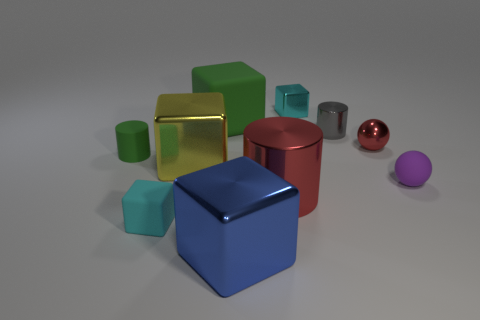How many green objects are small objects or tiny shiny cubes?
Give a very brief answer. 1. What number of yellow cylinders are the same size as the green rubber cube?
Your answer should be very brief. 0. The metallic object that is the same color as the tiny rubber block is what shape?
Make the answer very short. Cube. What number of things are either large red metallic objects or large metallic things left of the large red metallic cylinder?
Make the answer very short. 3. Does the shiny block that is to the right of the blue cube have the same size as the rubber object right of the tiny red metallic ball?
Give a very brief answer. Yes. How many small green rubber objects have the same shape as the cyan rubber thing?
Your answer should be very brief. 0. What shape is the small gray thing that is made of the same material as the red ball?
Ensure brevity in your answer.  Cylinder. There is a small cyan object that is in front of the rubber object that is to the right of the block that is behind the green matte cube; what is it made of?
Provide a succinct answer. Rubber. There is a purple matte sphere; is it the same size as the cyan object that is on the right side of the big blue cube?
Keep it short and to the point. Yes. What is the material of the other object that is the same shape as the small purple object?
Your response must be concise. Metal. 